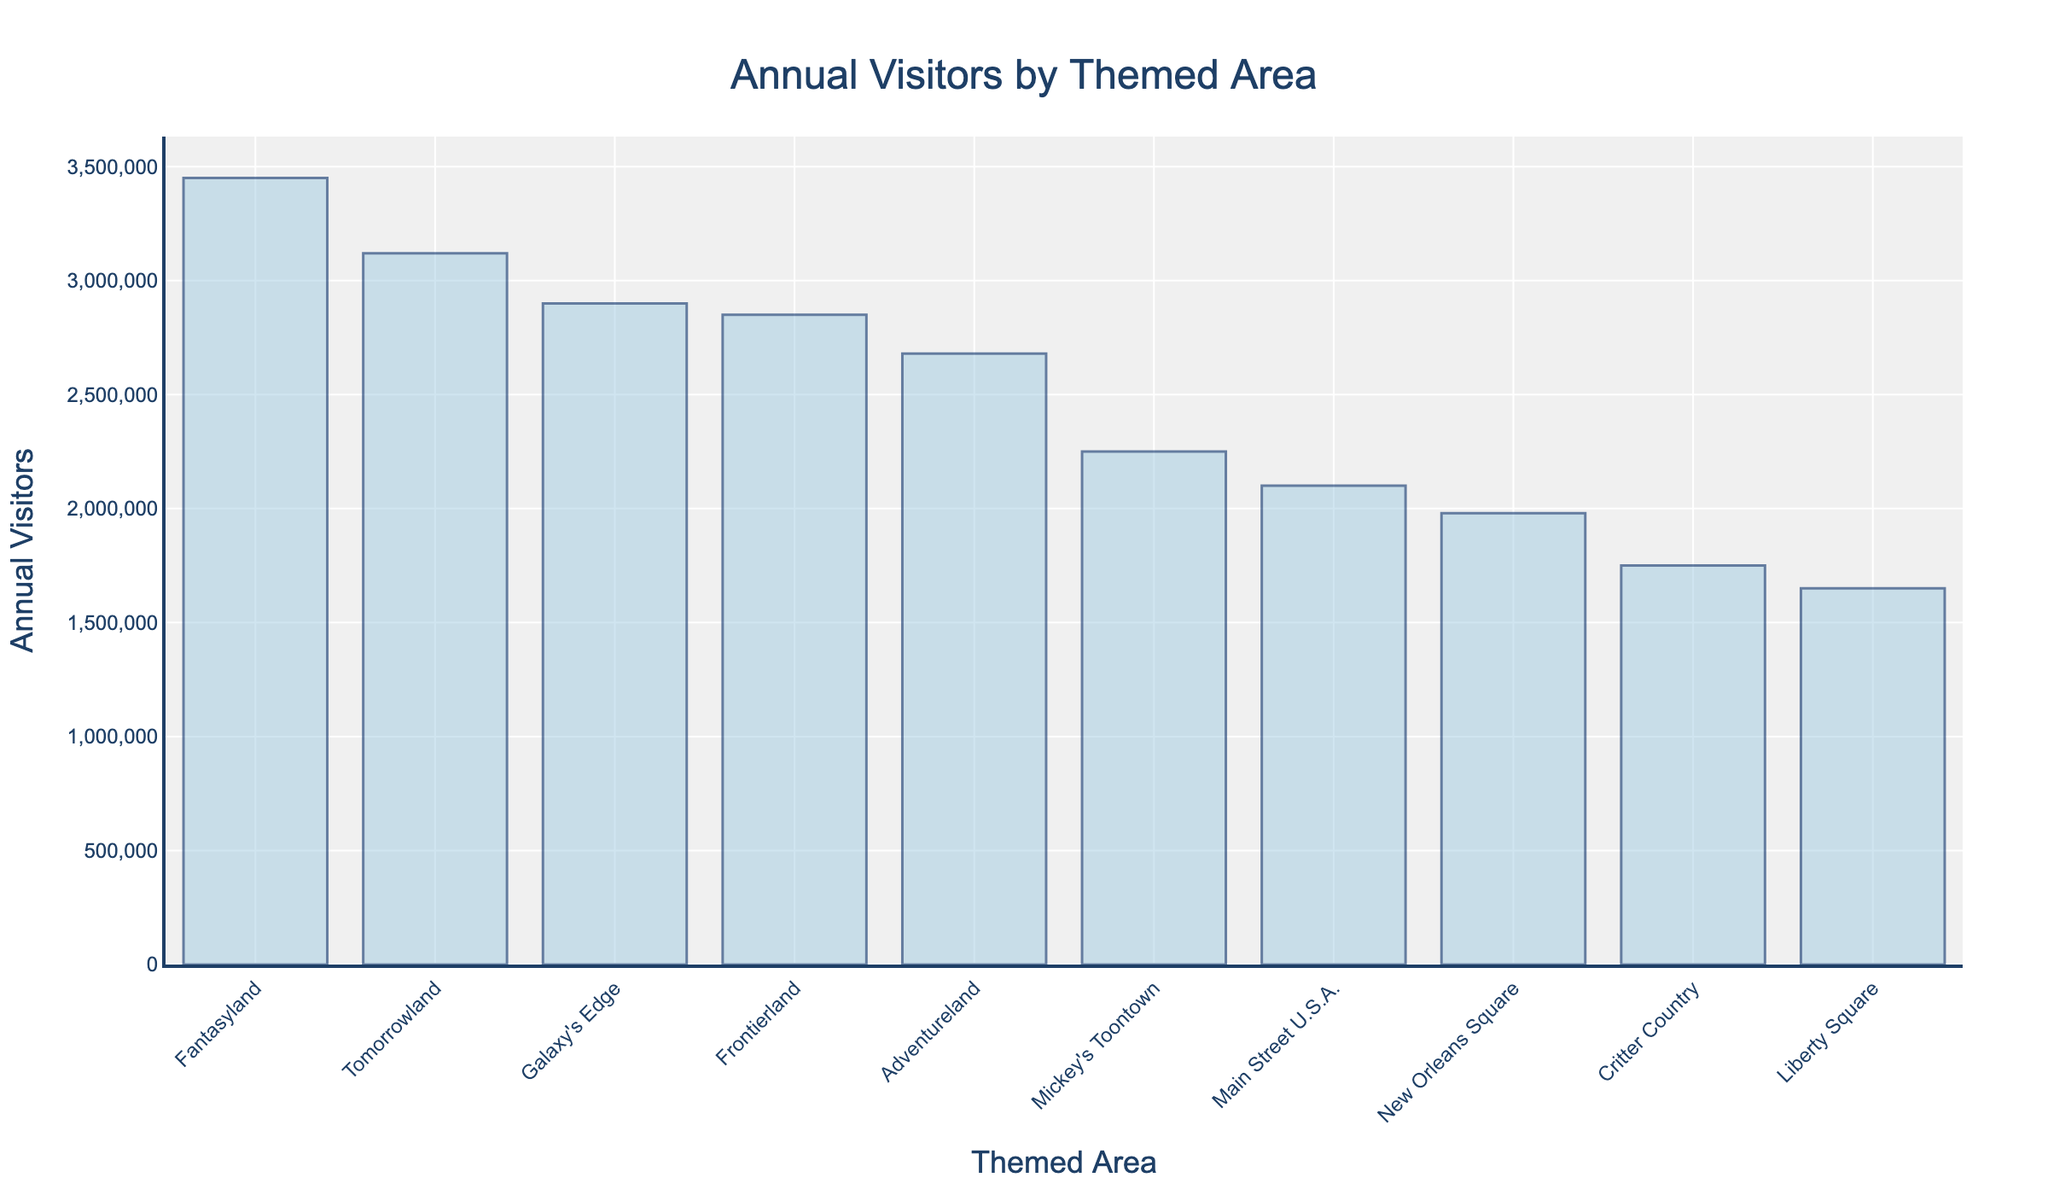What themed area has the highest number of annual visitors? The themed area with the highest bar represents the highest number of annual visitors. According to the chart, Fantasyland has the tallest bar and thus the highest number of annual visitors.
Answer: Fantasyland What is the total number of annual visitors for Frontierland and Liberty Square combined? Adding the annual visitors for Frontierland (2,850,000) and Liberty Square (1,650,000) gives 4,500,000.
Answer: 4,500,000 Which themed area receives more annual visitors: Galaxy's Edge or Tomorrowland? By comparing the bar heights for Galaxy's Edge (2,900,000) and Tomorrowland (3,120,000), it can be seen that Tomorrowland has more annual visitors.
Answer: Tomorrowland How many more visitors does Fantasyland have compared to Adventureland? Subtract the number of annual visitors in Adventureland (2,680,000) from Fantasyland (3,450,000) to get 770,000.
Answer: 770,000 Which themed area has fewer than 200,000 annual visitors? By looking at the bars shorter than the others, it is evident that Liberty Square has the shortest bar with 1,650,000 visitors, which is fewer than 200,000.
Answer: Liberty Square What is the average number of annual visitors across all themed areas? Add the number of annual visitors for all themed areas (totaling 25,860,000), then divide by the number of themed areas (10). The calculation is 25,860,000 / 10, which equals 2,586,000.
Answer: 2,586,000 Rank the top three themed areas by number of annual visitors. Sorting the themed areas by the height of their bars, the top three are Fantasyland (3,450,000), Tomorrowland (3,120,000), and Galaxy's Edge (2,900,000).
Answer: Fantasyland, Tomorrowland, Galaxy's Edge Which themed areas have between 2,000,000 and 3,000,000 annual visitors? By selecting the bars falling between 2,000,000 and 3,000,000 visitors mark, we find that Frontierland, Adventureland, and Galaxy's Edge fit this criteria.
Answer: Frontierland, Adventureland, Galaxy's Edge Which themed areas have fewer visitors than Main Street U.S.A.? Identify bars shorter than Main Street U.S.A.’s, which has 2,100,000 visitors. The themed areas are New Orleans Square (1,980,000), Critter Country (1,750,000), and Liberty Square (1,650,000).
Answer: New Orleans Square, Critter Country, Liberty Square 